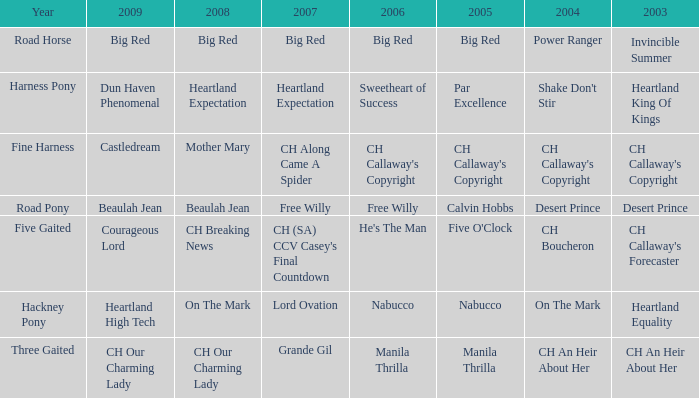What is the 2007 for the 2003 desert prince? Free Willy. 